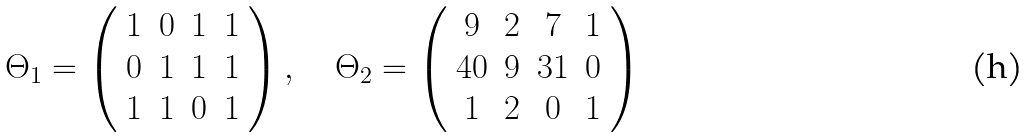Convert formula to latex. <formula><loc_0><loc_0><loc_500><loc_500>\Theta _ { 1 } = \left ( \begin{array} { c c c c } 1 & 0 & 1 & 1 \\ 0 & 1 & 1 & 1 \\ 1 & 1 & 0 & 1 \\ \end{array} \right ) , \quad \Theta _ { 2 } = \left ( \begin{array} { c c c c } 9 & 2 & 7 & 1 \\ 4 0 & 9 & 3 1 & 0 \\ 1 & 2 & 0 & 1 \\ \end{array} \right )</formula> 